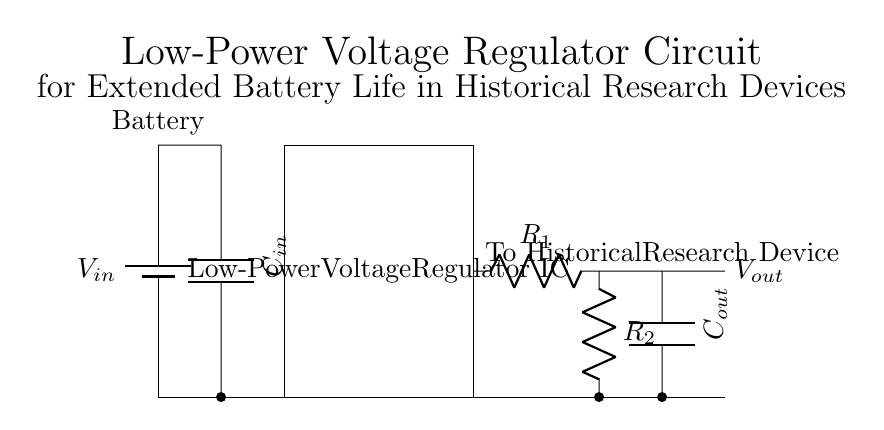What is the purpose of the capacitor labeled C_in? The capacitor C_in is used for input filtering to stabilize the input voltage and smooth out any fluctuations from the battery. It helps maintain a consistent voltage supply.
Answer: Input filtering What is the function of the low-power voltage regulator IC? The low-power voltage regulator IC maintains a constant output voltage, even when input voltage or load conditions vary, ensuring the downstream devices receive stable power.
Answer: Regulation What connects to the output terminal labeled V_out? The output terminal V_out connects to the historical research device, providing it with the regulated voltage necessary for operation.
Answer: Historical research device What are R_1 and R_2 used for? Resistors R_1 and R_2 are used in a voltage divider configuration to set the output voltage level provided by the regulator. They determine the feedback voltage for stable regulation.
Answer: Voltage setting How many capacitors are in the circuit? There are two capacitors in the circuit: C_in and C_out, which function for input filtering and output stabilization, respectively.
Answer: Two What is the voltage source in this circuit? The voltage source in this circuit is the battery labeled V_in, which provides the initial power input for the regulator.
Answer: Battery What is the significance of including capacitors C_in and C_out in the circuit? The capacitors C_in and C_out help filter and stabilize input and output voltages, respectively, which is crucial for efficient power delivery and extended battery life in devices.
Answer: Voltage stability 